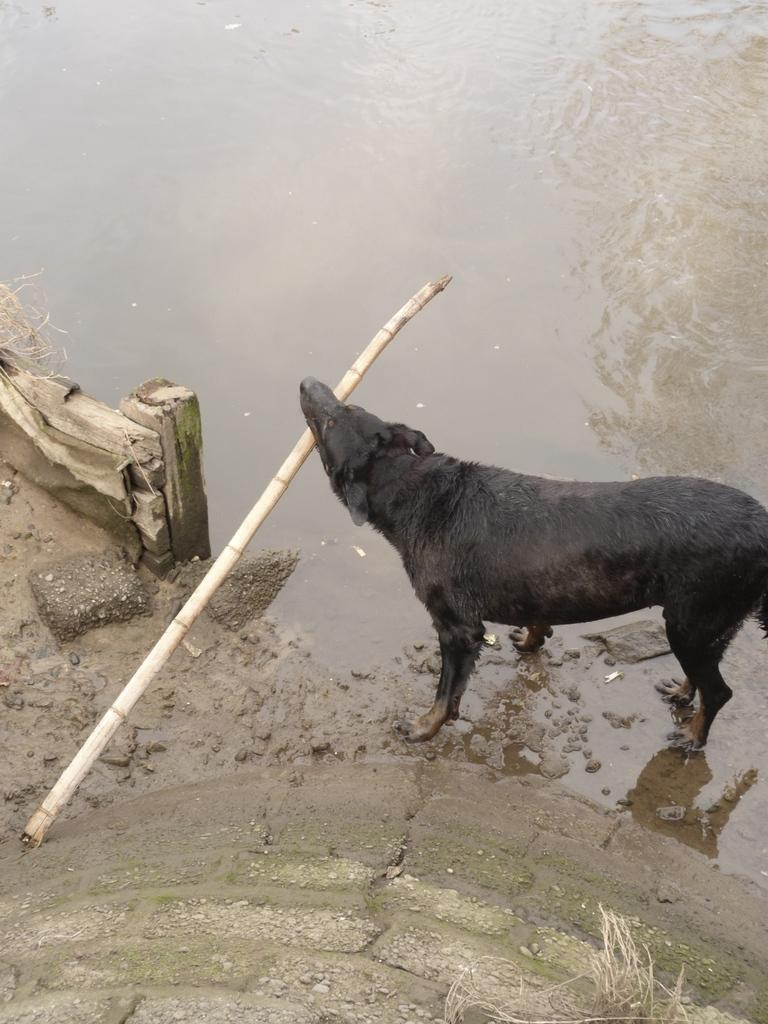What type of animal is in the image? There is a black color dog in the image. What is the dog doing in the image? The dog is standing and holding a stick with its mouth. What can be seen in the background of the image? There is water in the image. What is present at the bottom of the image? There are stones visible at the bottom of the image. What type of structure can be seen at the edge of the water in the image? There is no structure visible at the edge of the water in the image. 